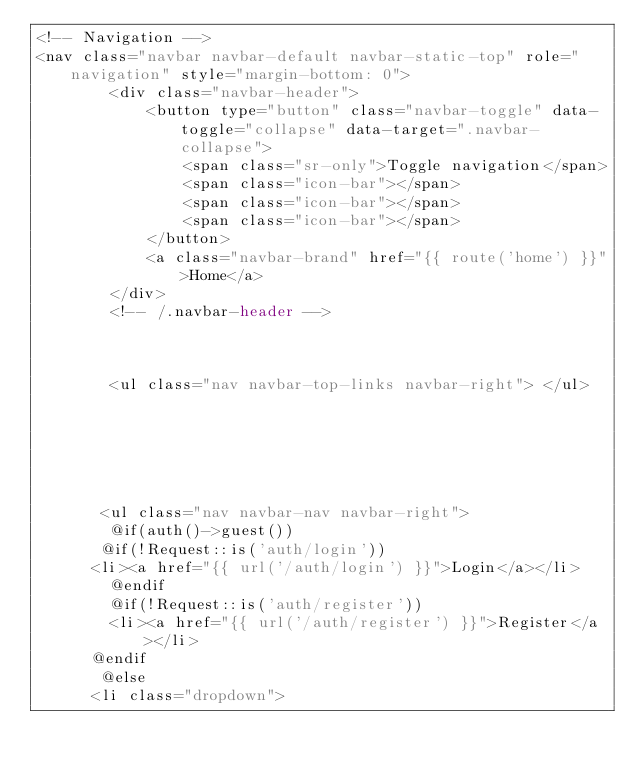<code> <loc_0><loc_0><loc_500><loc_500><_PHP_><!-- Navigation -->
<nav class="navbar navbar-default navbar-static-top" role="navigation" style="margin-bottom: 0">
        <div class="navbar-header">
            <button type="button" class="navbar-toggle" data-toggle="collapse" data-target=".navbar-collapse">
                <span class="sr-only">Toggle navigation</span>
                <span class="icon-bar"></span>
                <span class="icon-bar"></span>
                <span class="icon-bar"></span>
            </button>
            <a class="navbar-brand" href="{{ route('home') }}">Home</a>
        </div>
        <!-- /.navbar-header -->



        <ul class="nav navbar-top-links navbar-right"> </ul>






       <ul class="nav navbar-nav navbar-right">
        @if(auth()->guest())
       @if(!Request::is('auth/login'))
      <li><a href="{{ url('/auth/login') }}">Login</a></li>
        @endif
        @if(!Request::is('auth/register'))
        <li><a href="{{ url('/auth/register') }}">Register</a></li>
      @endif
       @else
      <li class="dropdown"></code> 